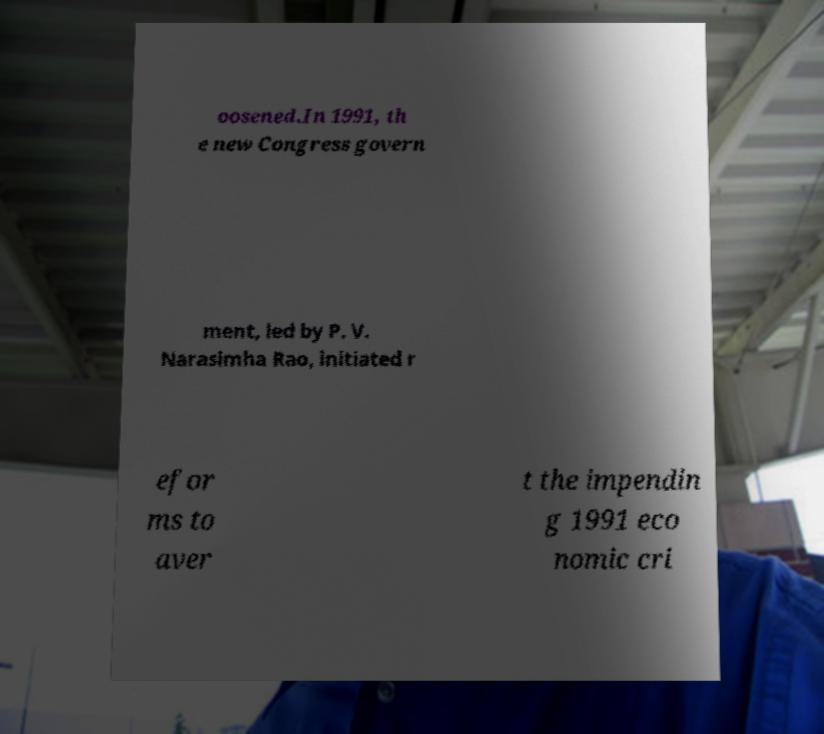Please identify and transcribe the text found in this image. oosened.In 1991, th e new Congress govern ment, led by P. V. Narasimha Rao, initiated r efor ms to aver t the impendin g 1991 eco nomic cri 